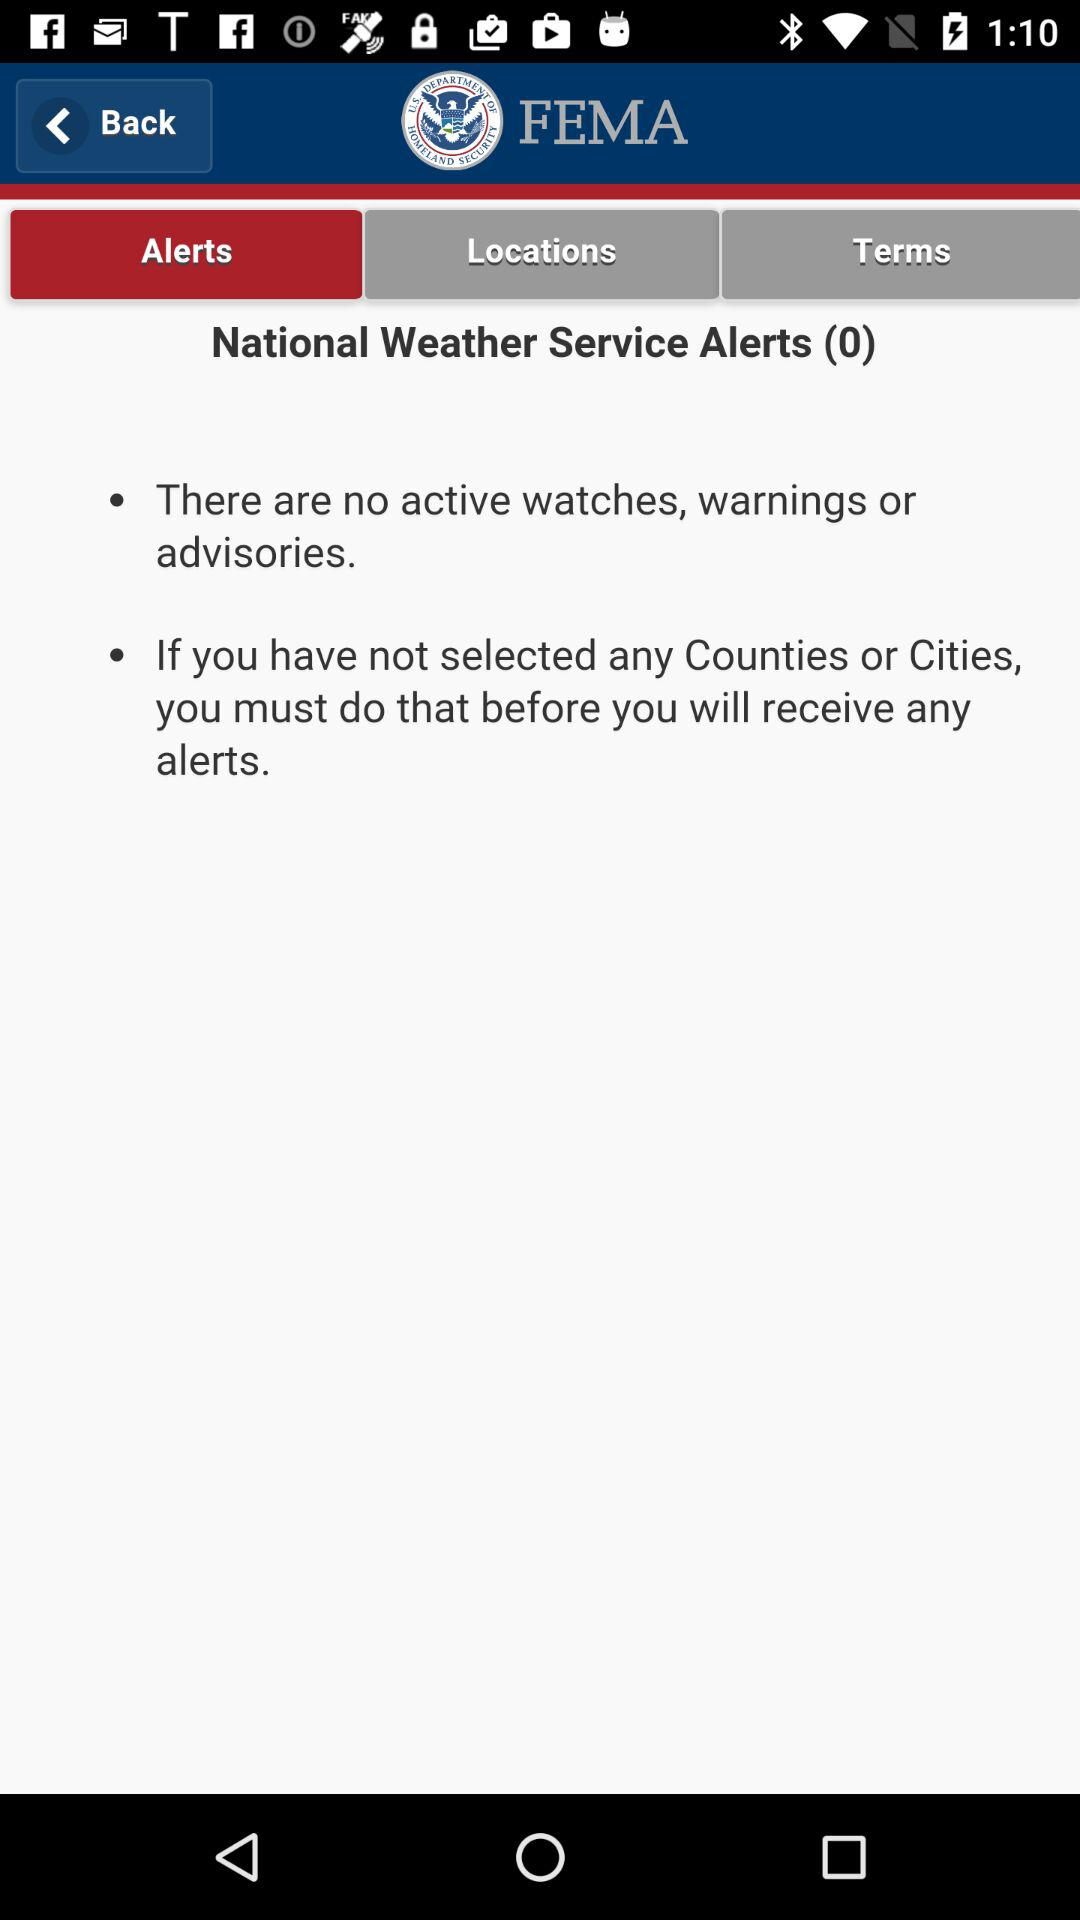How many "National Weather Service Alerts" are there? There are 0 "National Weather Service Alerts". 